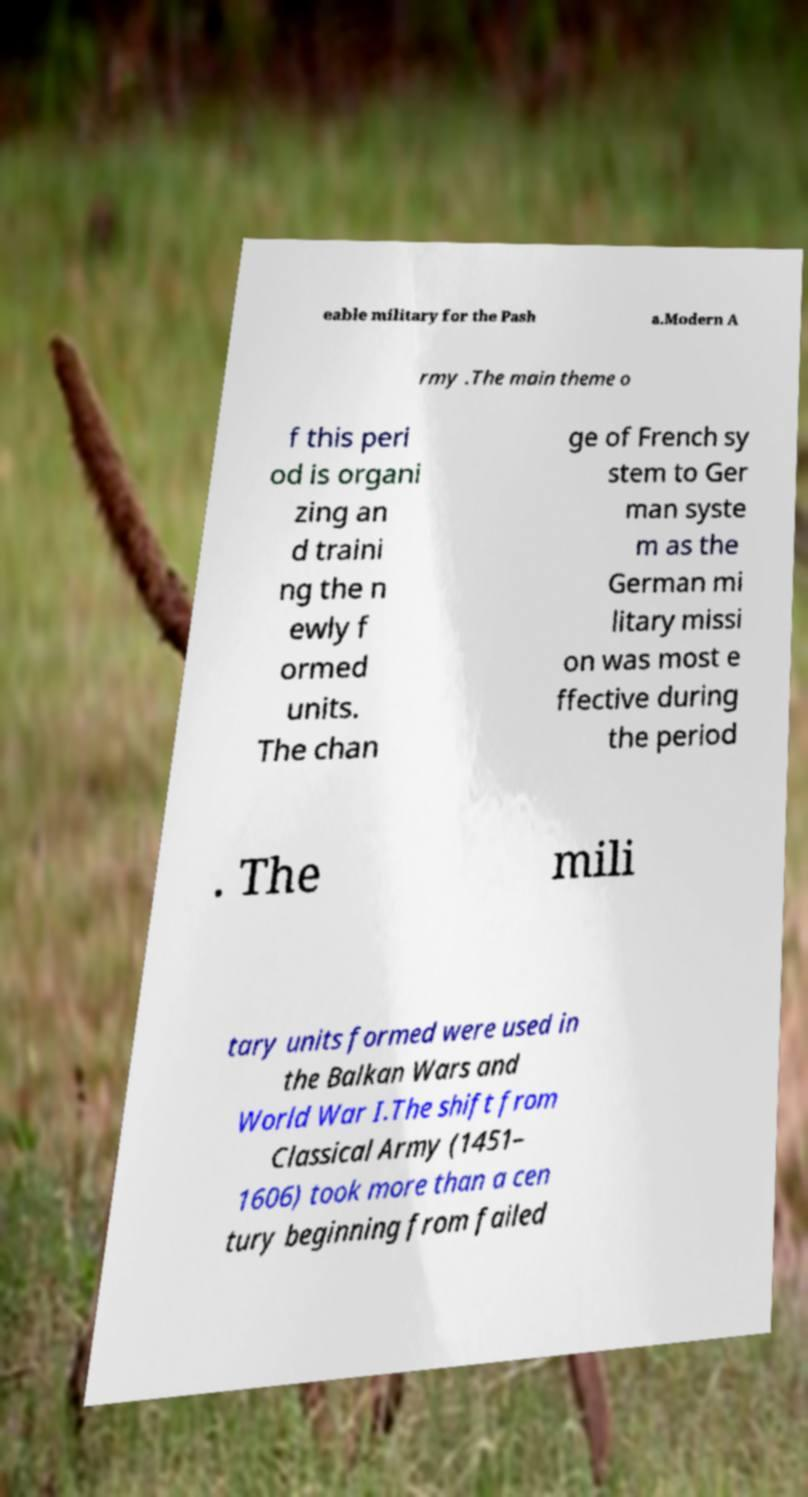For documentation purposes, I need the text within this image transcribed. Could you provide that? eable military for the Pash a.Modern A rmy .The main theme o f this peri od is organi zing an d traini ng the n ewly f ormed units. The chan ge of French sy stem to Ger man syste m as the German mi litary missi on was most e ffective during the period . The mili tary units formed were used in the Balkan Wars and World War I.The shift from Classical Army (1451– 1606) took more than a cen tury beginning from failed 